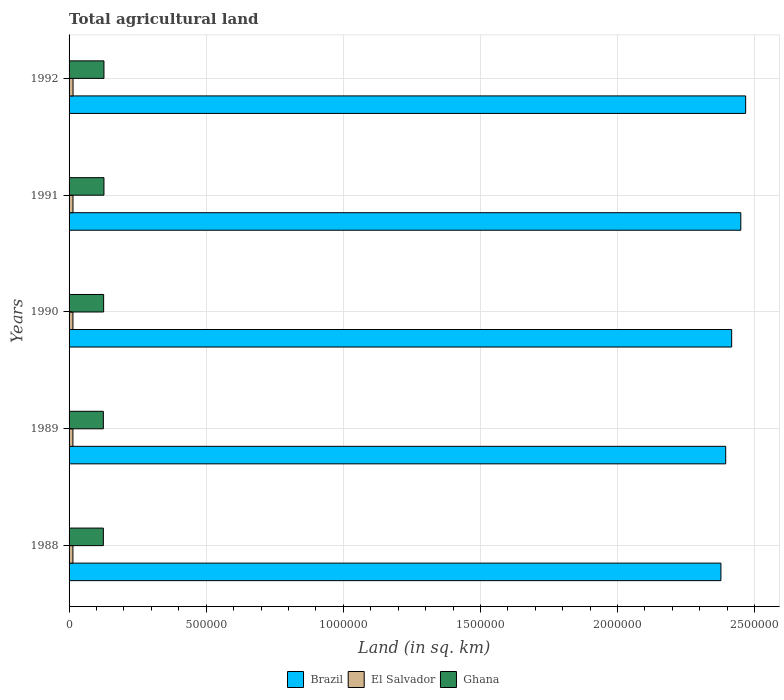How many different coloured bars are there?
Your answer should be compact. 3. How many groups of bars are there?
Offer a terse response. 5. Are the number of bars on each tick of the Y-axis equal?
Offer a very short reply. Yes. How many bars are there on the 2nd tick from the bottom?
Ensure brevity in your answer.  3. In how many cases, is the number of bars for a given year not equal to the number of legend labels?
Give a very brief answer. 0. What is the total agricultural land in Ghana in 1988?
Keep it short and to the point. 1.25e+05. Across all years, what is the maximum total agricultural land in El Salvador?
Your answer should be very brief. 1.45e+04. Across all years, what is the minimum total agricultural land in Ghana?
Your answer should be compact. 1.25e+05. In which year was the total agricultural land in Ghana maximum?
Provide a succinct answer. 1991. In which year was the total agricultural land in El Salvador minimum?
Provide a short and direct response. 1988. What is the total total agricultural land in Brazil in the graph?
Your response must be concise. 1.21e+07. What is the difference between the total agricultural land in El Salvador in 1989 and that in 1990?
Offer a very short reply. -30. What is the difference between the total agricultural land in Brazil in 1990 and the total agricultural land in El Salvador in 1988?
Your response must be concise. 2.40e+06. What is the average total agricultural land in El Salvador per year?
Your answer should be compact. 1.42e+04. In the year 1989, what is the difference between the total agricultural land in Ghana and total agricultural land in Brazil?
Your response must be concise. -2.27e+06. What is the ratio of the total agricultural land in Ghana in 1989 to that in 1992?
Make the answer very short. 0.98. What is the difference between the highest and the second highest total agricultural land in Brazil?
Your answer should be compact. 1.77e+04. What is the difference between the highest and the lowest total agricultural land in Ghana?
Ensure brevity in your answer.  2200. Is the sum of the total agricultural land in Ghana in 1989 and 1990 greater than the maximum total agricultural land in El Salvador across all years?
Offer a terse response. Yes. What does the 3rd bar from the top in 1988 represents?
Offer a terse response. Brazil. What does the 2nd bar from the bottom in 1988 represents?
Give a very brief answer. El Salvador. How many bars are there?
Your answer should be very brief. 15. Are all the bars in the graph horizontal?
Provide a succinct answer. Yes. How many years are there in the graph?
Give a very brief answer. 5. What is the difference between two consecutive major ticks on the X-axis?
Give a very brief answer. 5.00e+05. Are the values on the major ticks of X-axis written in scientific E-notation?
Your answer should be compact. No. Does the graph contain grids?
Ensure brevity in your answer.  Yes. How many legend labels are there?
Offer a terse response. 3. How are the legend labels stacked?
Give a very brief answer. Horizontal. What is the title of the graph?
Your answer should be compact. Total agricultural land. What is the label or title of the X-axis?
Keep it short and to the point. Land (in sq. km). What is the Land (in sq. km) in Brazil in 1988?
Make the answer very short. 2.38e+06. What is the Land (in sq. km) of El Salvador in 1988?
Provide a short and direct response. 1.41e+04. What is the Land (in sq. km) in Ghana in 1988?
Offer a terse response. 1.25e+05. What is the Land (in sq. km) of Brazil in 1989?
Your answer should be very brief. 2.39e+06. What is the Land (in sq. km) of El Salvador in 1989?
Provide a short and direct response. 1.41e+04. What is the Land (in sq. km) in Ghana in 1989?
Offer a very short reply. 1.25e+05. What is the Land (in sq. km) in Brazil in 1990?
Offer a terse response. 2.42e+06. What is the Land (in sq. km) in El Salvador in 1990?
Your answer should be very brief. 1.41e+04. What is the Land (in sq. km) of Ghana in 1990?
Provide a succinct answer. 1.26e+05. What is the Land (in sq. km) in Brazil in 1991?
Provide a short and direct response. 2.45e+06. What is the Land (in sq. km) of El Salvador in 1991?
Keep it short and to the point. 1.43e+04. What is the Land (in sq. km) in Ghana in 1991?
Give a very brief answer. 1.27e+05. What is the Land (in sq. km) in Brazil in 1992?
Offer a terse response. 2.47e+06. What is the Land (in sq. km) in El Salvador in 1992?
Provide a short and direct response. 1.45e+04. What is the Land (in sq. km) of Ghana in 1992?
Offer a very short reply. 1.27e+05. Across all years, what is the maximum Land (in sq. km) of Brazil?
Offer a very short reply. 2.47e+06. Across all years, what is the maximum Land (in sq. km) in El Salvador?
Provide a succinct answer. 1.45e+04. Across all years, what is the maximum Land (in sq. km) in Ghana?
Your answer should be compact. 1.27e+05. Across all years, what is the minimum Land (in sq. km) in Brazil?
Make the answer very short. 2.38e+06. Across all years, what is the minimum Land (in sq. km) in El Salvador?
Ensure brevity in your answer.  1.41e+04. Across all years, what is the minimum Land (in sq. km) in Ghana?
Provide a succinct answer. 1.25e+05. What is the total Land (in sq. km) of Brazil in the graph?
Make the answer very short. 1.21e+07. What is the total Land (in sq. km) in El Salvador in the graph?
Offer a very short reply. 7.10e+04. What is the total Land (in sq. km) of Ghana in the graph?
Your response must be concise. 6.30e+05. What is the difference between the Land (in sq. km) in Brazil in 1988 and that in 1989?
Ensure brevity in your answer.  -1.74e+04. What is the difference between the Land (in sq. km) in Ghana in 1988 and that in 1989?
Your answer should be very brief. 0. What is the difference between the Land (in sq. km) in Brazil in 1988 and that in 1990?
Your answer should be very brief. -3.92e+04. What is the difference between the Land (in sq. km) in El Salvador in 1988 and that in 1990?
Provide a succinct answer. -30. What is the difference between the Land (in sq. km) in Ghana in 1988 and that in 1990?
Provide a short and direct response. -1050. What is the difference between the Land (in sq. km) of Brazil in 1988 and that in 1991?
Make the answer very short. -7.25e+04. What is the difference between the Land (in sq. km) of El Salvador in 1988 and that in 1991?
Keep it short and to the point. -210. What is the difference between the Land (in sq. km) in Ghana in 1988 and that in 1991?
Your answer should be very brief. -2200. What is the difference between the Land (in sq. km) of Brazil in 1988 and that in 1992?
Your answer should be very brief. -9.02e+04. What is the difference between the Land (in sq. km) of El Salvador in 1988 and that in 1992?
Make the answer very short. -440. What is the difference between the Land (in sq. km) of Ghana in 1988 and that in 1992?
Your answer should be very brief. -2200. What is the difference between the Land (in sq. km) in Brazil in 1989 and that in 1990?
Ensure brevity in your answer.  -2.18e+04. What is the difference between the Land (in sq. km) in El Salvador in 1989 and that in 1990?
Make the answer very short. -30. What is the difference between the Land (in sq. km) in Ghana in 1989 and that in 1990?
Ensure brevity in your answer.  -1050. What is the difference between the Land (in sq. km) in Brazil in 1989 and that in 1991?
Offer a very short reply. -5.51e+04. What is the difference between the Land (in sq. km) of El Salvador in 1989 and that in 1991?
Your answer should be very brief. -210. What is the difference between the Land (in sq. km) of Ghana in 1989 and that in 1991?
Ensure brevity in your answer.  -2200. What is the difference between the Land (in sq. km) of Brazil in 1989 and that in 1992?
Provide a short and direct response. -7.28e+04. What is the difference between the Land (in sq. km) of El Salvador in 1989 and that in 1992?
Give a very brief answer. -440. What is the difference between the Land (in sq. km) of Ghana in 1989 and that in 1992?
Give a very brief answer. -2200. What is the difference between the Land (in sq. km) in Brazil in 1990 and that in 1991?
Give a very brief answer. -3.33e+04. What is the difference between the Land (in sq. km) of El Salvador in 1990 and that in 1991?
Make the answer very short. -180. What is the difference between the Land (in sq. km) of Ghana in 1990 and that in 1991?
Provide a succinct answer. -1150. What is the difference between the Land (in sq. km) of Brazil in 1990 and that in 1992?
Give a very brief answer. -5.10e+04. What is the difference between the Land (in sq. km) of El Salvador in 1990 and that in 1992?
Give a very brief answer. -410. What is the difference between the Land (in sq. km) in Ghana in 1990 and that in 1992?
Your response must be concise. -1150. What is the difference between the Land (in sq. km) of Brazil in 1991 and that in 1992?
Make the answer very short. -1.77e+04. What is the difference between the Land (in sq. km) in El Salvador in 1991 and that in 1992?
Make the answer very short. -230. What is the difference between the Land (in sq. km) in Brazil in 1988 and the Land (in sq. km) in El Salvador in 1989?
Your response must be concise. 2.36e+06. What is the difference between the Land (in sq. km) of Brazil in 1988 and the Land (in sq. km) of Ghana in 1989?
Your response must be concise. 2.25e+06. What is the difference between the Land (in sq. km) in El Salvador in 1988 and the Land (in sq. km) in Ghana in 1989?
Your answer should be compact. -1.11e+05. What is the difference between the Land (in sq. km) in Brazil in 1988 and the Land (in sq. km) in El Salvador in 1990?
Provide a short and direct response. 2.36e+06. What is the difference between the Land (in sq. km) of Brazil in 1988 and the Land (in sq. km) of Ghana in 1990?
Provide a short and direct response. 2.25e+06. What is the difference between the Land (in sq. km) in El Salvador in 1988 and the Land (in sq. km) in Ghana in 1990?
Offer a terse response. -1.12e+05. What is the difference between the Land (in sq. km) in Brazil in 1988 and the Land (in sq. km) in El Salvador in 1991?
Give a very brief answer. 2.36e+06. What is the difference between the Land (in sq. km) of Brazil in 1988 and the Land (in sq. km) of Ghana in 1991?
Ensure brevity in your answer.  2.25e+06. What is the difference between the Land (in sq. km) in El Salvador in 1988 and the Land (in sq. km) in Ghana in 1991?
Your answer should be compact. -1.13e+05. What is the difference between the Land (in sq. km) in Brazil in 1988 and the Land (in sq. km) in El Salvador in 1992?
Keep it short and to the point. 2.36e+06. What is the difference between the Land (in sq. km) of Brazil in 1988 and the Land (in sq. km) of Ghana in 1992?
Provide a succinct answer. 2.25e+06. What is the difference between the Land (in sq. km) in El Salvador in 1988 and the Land (in sq. km) in Ghana in 1992?
Provide a short and direct response. -1.13e+05. What is the difference between the Land (in sq. km) of Brazil in 1989 and the Land (in sq. km) of El Salvador in 1990?
Your answer should be compact. 2.38e+06. What is the difference between the Land (in sq. km) of Brazil in 1989 and the Land (in sq. km) of Ghana in 1990?
Your answer should be compact. 2.27e+06. What is the difference between the Land (in sq. km) in El Salvador in 1989 and the Land (in sq. km) in Ghana in 1990?
Your answer should be very brief. -1.12e+05. What is the difference between the Land (in sq. km) in Brazil in 1989 and the Land (in sq. km) in El Salvador in 1991?
Ensure brevity in your answer.  2.38e+06. What is the difference between the Land (in sq. km) in Brazil in 1989 and the Land (in sq. km) in Ghana in 1991?
Offer a terse response. 2.27e+06. What is the difference between the Land (in sq. km) in El Salvador in 1989 and the Land (in sq. km) in Ghana in 1991?
Provide a succinct answer. -1.13e+05. What is the difference between the Land (in sq. km) of Brazil in 1989 and the Land (in sq. km) of El Salvador in 1992?
Provide a succinct answer. 2.38e+06. What is the difference between the Land (in sq. km) of Brazil in 1989 and the Land (in sq. km) of Ghana in 1992?
Your answer should be very brief. 2.27e+06. What is the difference between the Land (in sq. km) in El Salvador in 1989 and the Land (in sq. km) in Ghana in 1992?
Make the answer very short. -1.13e+05. What is the difference between the Land (in sq. km) in Brazil in 1990 and the Land (in sq. km) in El Salvador in 1991?
Offer a very short reply. 2.40e+06. What is the difference between the Land (in sq. km) in Brazil in 1990 and the Land (in sq. km) in Ghana in 1991?
Provide a succinct answer. 2.29e+06. What is the difference between the Land (in sq. km) in El Salvador in 1990 and the Land (in sq. km) in Ghana in 1991?
Your response must be concise. -1.13e+05. What is the difference between the Land (in sq. km) in Brazil in 1990 and the Land (in sq. km) in El Salvador in 1992?
Provide a succinct answer. 2.40e+06. What is the difference between the Land (in sq. km) in Brazil in 1990 and the Land (in sq. km) in Ghana in 1992?
Make the answer very short. 2.29e+06. What is the difference between the Land (in sq. km) in El Salvador in 1990 and the Land (in sq. km) in Ghana in 1992?
Provide a succinct answer. -1.13e+05. What is the difference between the Land (in sq. km) of Brazil in 1991 and the Land (in sq. km) of El Salvador in 1992?
Your response must be concise. 2.43e+06. What is the difference between the Land (in sq. km) in Brazil in 1991 and the Land (in sq. km) in Ghana in 1992?
Your response must be concise. 2.32e+06. What is the difference between the Land (in sq. km) in El Salvador in 1991 and the Land (in sq. km) in Ghana in 1992?
Make the answer very short. -1.13e+05. What is the average Land (in sq. km) of Brazil per year?
Ensure brevity in your answer.  2.42e+06. What is the average Land (in sq. km) in El Salvador per year?
Provide a succinct answer. 1.42e+04. What is the average Land (in sq. km) in Ghana per year?
Ensure brevity in your answer.  1.26e+05. In the year 1988, what is the difference between the Land (in sq. km) of Brazil and Land (in sq. km) of El Salvador?
Make the answer very short. 2.36e+06. In the year 1988, what is the difference between the Land (in sq. km) of Brazil and Land (in sq. km) of Ghana?
Provide a succinct answer. 2.25e+06. In the year 1988, what is the difference between the Land (in sq. km) of El Salvador and Land (in sq. km) of Ghana?
Ensure brevity in your answer.  -1.11e+05. In the year 1989, what is the difference between the Land (in sq. km) of Brazil and Land (in sq. km) of El Salvador?
Ensure brevity in your answer.  2.38e+06. In the year 1989, what is the difference between the Land (in sq. km) in Brazil and Land (in sq. km) in Ghana?
Offer a very short reply. 2.27e+06. In the year 1989, what is the difference between the Land (in sq. km) in El Salvador and Land (in sq. km) in Ghana?
Give a very brief answer. -1.11e+05. In the year 1990, what is the difference between the Land (in sq. km) in Brazil and Land (in sq. km) in El Salvador?
Provide a succinct answer. 2.40e+06. In the year 1990, what is the difference between the Land (in sq. km) of Brazil and Land (in sq. km) of Ghana?
Provide a succinct answer. 2.29e+06. In the year 1990, what is the difference between the Land (in sq. km) in El Salvador and Land (in sq. km) in Ghana?
Your response must be concise. -1.12e+05. In the year 1991, what is the difference between the Land (in sq. km) in Brazil and Land (in sq. km) in El Salvador?
Your response must be concise. 2.44e+06. In the year 1991, what is the difference between the Land (in sq. km) of Brazil and Land (in sq. km) of Ghana?
Your answer should be very brief. 2.32e+06. In the year 1991, what is the difference between the Land (in sq. km) in El Salvador and Land (in sq. km) in Ghana?
Ensure brevity in your answer.  -1.13e+05. In the year 1992, what is the difference between the Land (in sq. km) of Brazil and Land (in sq. km) of El Salvador?
Ensure brevity in your answer.  2.45e+06. In the year 1992, what is the difference between the Land (in sq. km) of Brazil and Land (in sq. km) of Ghana?
Your response must be concise. 2.34e+06. In the year 1992, what is the difference between the Land (in sq. km) of El Salvador and Land (in sq. km) of Ghana?
Make the answer very short. -1.13e+05. What is the ratio of the Land (in sq. km) of El Salvador in 1988 to that in 1989?
Your response must be concise. 1. What is the ratio of the Land (in sq. km) of Brazil in 1988 to that in 1990?
Make the answer very short. 0.98. What is the ratio of the Land (in sq. km) of El Salvador in 1988 to that in 1990?
Make the answer very short. 1. What is the ratio of the Land (in sq. km) of Brazil in 1988 to that in 1991?
Provide a succinct answer. 0.97. What is the ratio of the Land (in sq. km) of El Salvador in 1988 to that in 1991?
Offer a terse response. 0.99. What is the ratio of the Land (in sq. km) in Ghana in 1988 to that in 1991?
Make the answer very short. 0.98. What is the ratio of the Land (in sq. km) in Brazil in 1988 to that in 1992?
Offer a very short reply. 0.96. What is the ratio of the Land (in sq. km) in El Salvador in 1988 to that in 1992?
Provide a short and direct response. 0.97. What is the ratio of the Land (in sq. km) of Ghana in 1988 to that in 1992?
Offer a very short reply. 0.98. What is the ratio of the Land (in sq. km) in Ghana in 1989 to that in 1990?
Provide a succinct answer. 0.99. What is the ratio of the Land (in sq. km) of Brazil in 1989 to that in 1991?
Your answer should be compact. 0.98. What is the ratio of the Land (in sq. km) in El Salvador in 1989 to that in 1991?
Keep it short and to the point. 0.99. What is the ratio of the Land (in sq. km) in Ghana in 1989 to that in 1991?
Keep it short and to the point. 0.98. What is the ratio of the Land (in sq. km) of Brazil in 1989 to that in 1992?
Provide a succinct answer. 0.97. What is the ratio of the Land (in sq. km) in El Salvador in 1989 to that in 1992?
Provide a short and direct response. 0.97. What is the ratio of the Land (in sq. km) in Ghana in 1989 to that in 1992?
Your response must be concise. 0.98. What is the ratio of the Land (in sq. km) in Brazil in 1990 to that in 1991?
Your response must be concise. 0.99. What is the ratio of the Land (in sq. km) in El Salvador in 1990 to that in 1991?
Give a very brief answer. 0.99. What is the ratio of the Land (in sq. km) of Brazil in 1990 to that in 1992?
Offer a very short reply. 0.98. What is the ratio of the Land (in sq. km) in El Salvador in 1990 to that in 1992?
Your answer should be compact. 0.97. What is the ratio of the Land (in sq. km) in Ghana in 1990 to that in 1992?
Your response must be concise. 0.99. What is the ratio of the Land (in sq. km) of Brazil in 1991 to that in 1992?
Give a very brief answer. 0.99. What is the ratio of the Land (in sq. km) in El Salvador in 1991 to that in 1992?
Ensure brevity in your answer.  0.98. What is the ratio of the Land (in sq. km) of Ghana in 1991 to that in 1992?
Provide a short and direct response. 1. What is the difference between the highest and the second highest Land (in sq. km) in Brazil?
Give a very brief answer. 1.77e+04. What is the difference between the highest and the second highest Land (in sq. km) of El Salvador?
Keep it short and to the point. 230. What is the difference between the highest and the lowest Land (in sq. km) in Brazil?
Offer a very short reply. 9.02e+04. What is the difference between the highest and the lowest Land (in sq. km) in El Salvador?
Your answer should be very brief. 440. What is the difference between the highest and the lowest Land (in sq. km) in Ghana?
Give a very brief answer. 2200. 